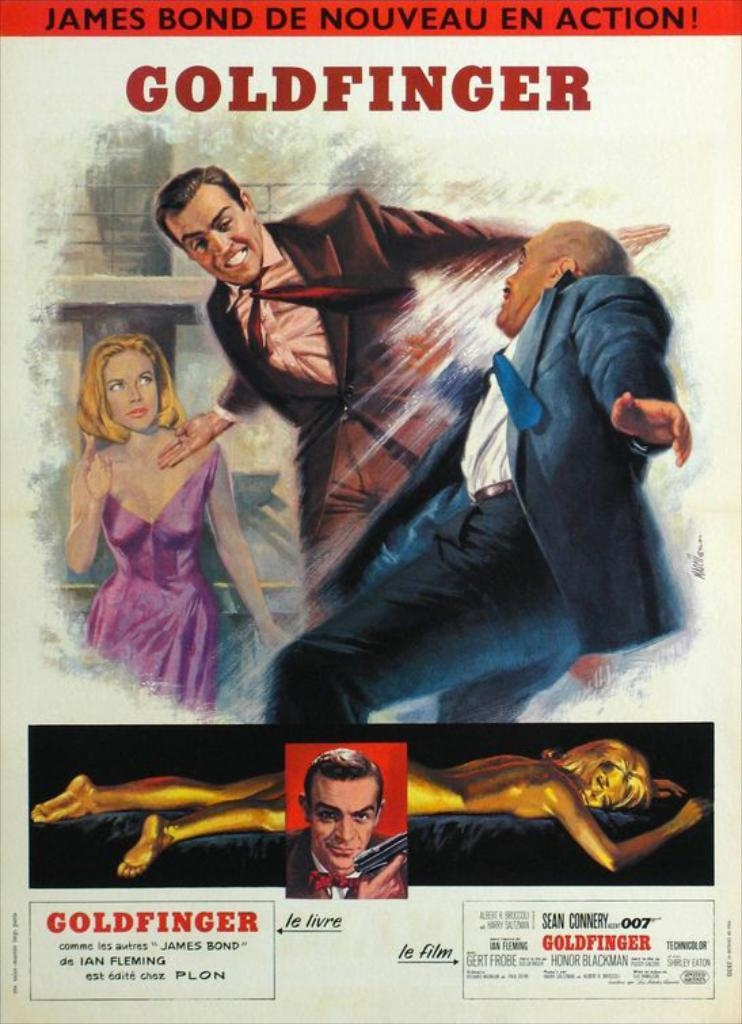<image>
Offer a succinct explanation of the picture presented. The European movie poster for the James Bond film "Goldfinger". 